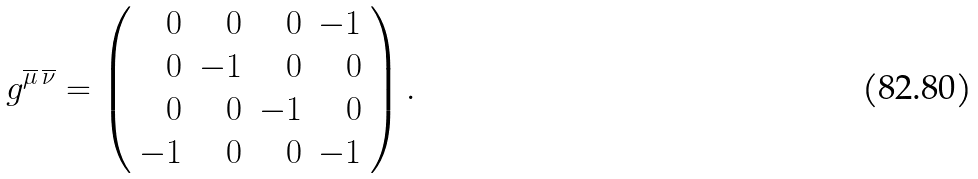<formula> <loc_0><loc_0><loc_500><loc_500>g ^ { \overline { \mu } \, \overline { \nu } } = \left ( \begin{array} { r r r r } 0 & 0 & 0 & - 1 \\ 0 & - 1 & 0 & 0 \\ 0 & 0 & - 1 & 0 \\ - 1 & 0 & 0 & - 1 \end{array} \right ) .</formula> 